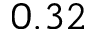<formula> <loc_0><loc_0><loc_500><loc_500>0 . 3 2</formula> 